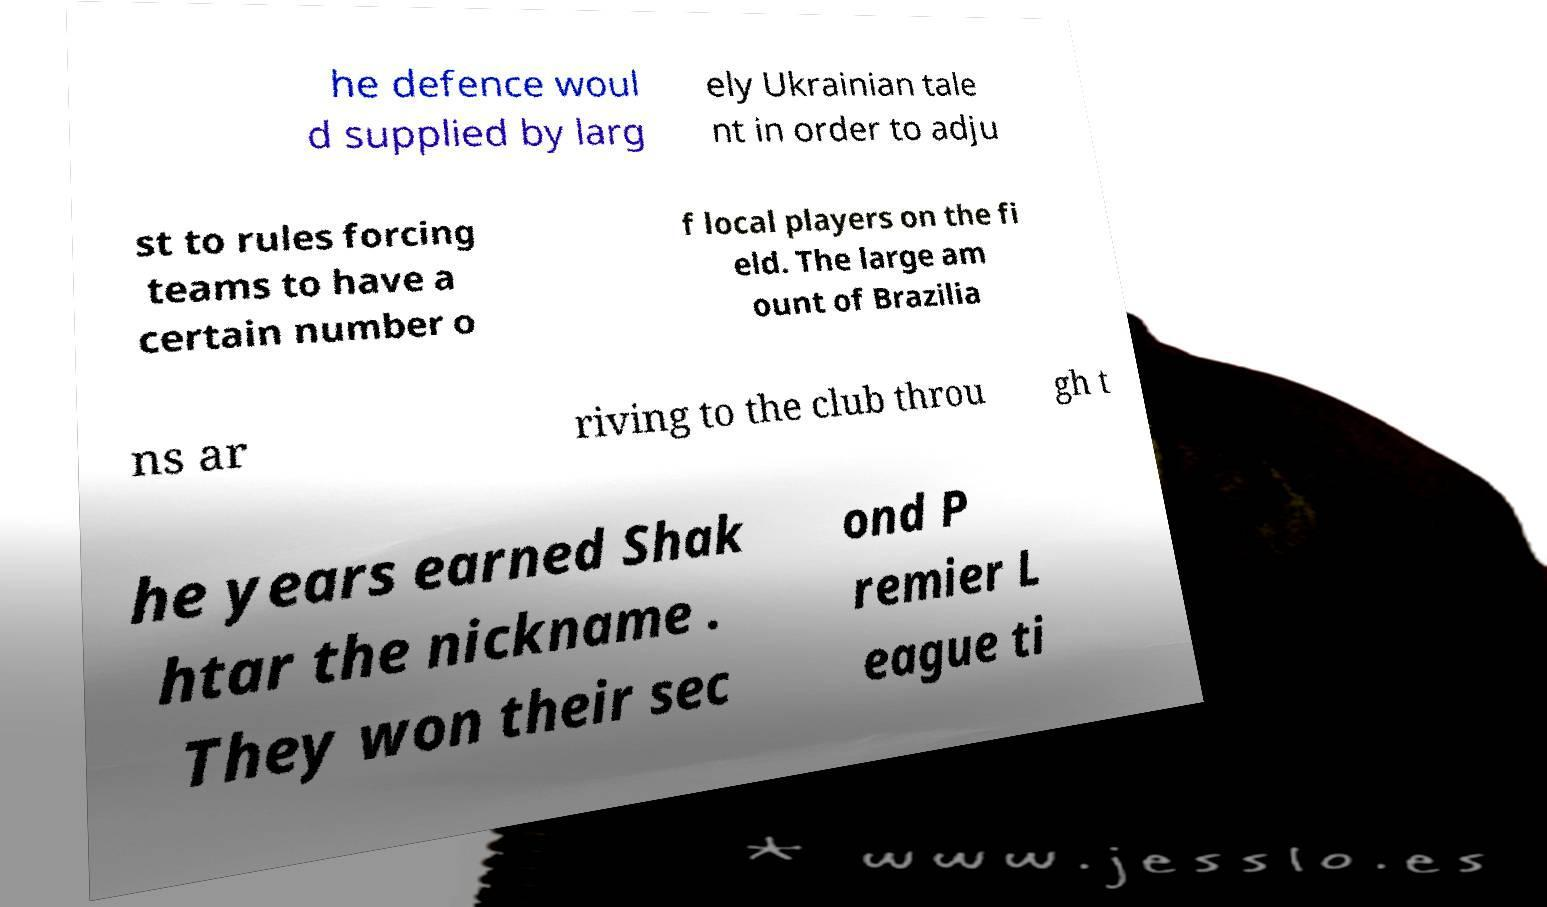Please read and relay the text visible in this image. What does it say? he defence woul d supplied by larg ely Ukrainian tale nt in order to adju st to rules forcing teams to have a certain number o f local players on the fi eld. The large am ount of Brazilia ns ar riving to the club throu gh t he years earned Shak htar the nickname . They won their sec ond P remier L eague ti 